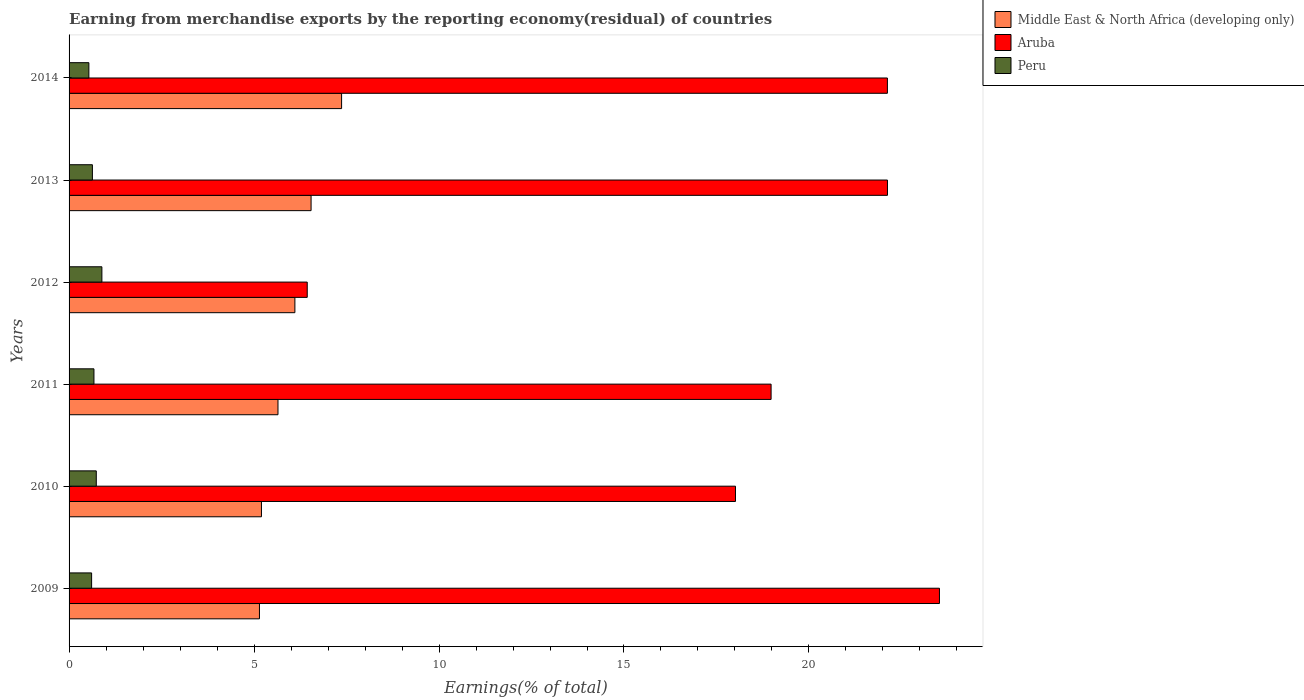Are the number of bars on each tick of the Y-axis equal?
Your response must be concise. Yes. How many bars are there on the 3rd tick from the bottom?
Give a very brief answer. 3. In how many cases, is the number of bars for a given year not equal to the number of legend labels?
Ensure brevity in your answer.  0. What is the percentage of amount earned from merchandise exports in Middle East & North Africa (developing only) in 2009?
Keep it short and to the point. 5.15. Across all years, what is the maximum percentage of amount earned from merchandise exports in Peru?
Make the answer very short. 0.89. Across all years, what is the minimum percentage of amount earned from merchandise exports in Peru?
Give a very brief answer. 0.54. In which year was the percentage of amount earned from merchandise exports in Peru maximum?
Provide a succinct answer. 2012. What is the total percentage of amount earned from merchandise exports in Aruba in the graph?
Make the answer very short. 111.2. What is the difference between the percentage of amount earned from merchandise exports in Middle East & North Africa (developing only) in 2011 and that in 2013?
Provide a short and direct response. -0.89. What is the difference between the percentage of amount earned from merchandise exports in Middle East & North Africa (developing only) in 2009 and the percentage of amount earned from merchandise exports in Peru in 2011?
Your answer should be very brief. 4.47. What is the average percentage of amount earned from merchandise exports in Aruba per year?
Provide a succinct answer. 18.53. In the year 2010, what is the difference between the percentage of amount earned from merchandise exports in Aruba and percentage of amount earned from merchandise exports in Peru?
Provide a short and direct response. 17.28. What is the ratio of the percentage of amount earned from merchandise exports in Peru in 2012 to that in 2014?
Give a very brief answer. 1.66. What is the difference between the highest and the second highest percentage of amount earned from merchandise exports in Peru?
Your response must be concise. 0.15. What is the difference between the highest and the lowest percentage of amount earned from merchandise exports in Aruba?
Make the answer very short. 17.09. In how many years, is the percentage of amount earned from merchandise exports in Aruba greater than the average percentage of amount earned from merchandise exports in Aruba taken over all years?
Your answer should be very brief. 4. Is the sum of the percentage of amount earned from merchandise exports in Peru in 2009 and 2012 greater than the maximum percentage of amount earned from merchandise exports in Middle East & North Africa (developing only) across all years?
Ensure brevity in your answer.  No. What does the 1st bar from the top in 2012 represents?
Offer a very short reply. Peru. What does the 3rd bar from the bottom in 2014 represents?
Offer a terse response. Peru. Is it the case that in every year, the sum of the percentage of amount earned from merchandise exports in Middle East & North Africa (developing only) and percentage of amount earned from merchandise exports in Aruba is greater than the percentage of amount earned from merchandise exports in Peru?
Keep it short and to the point. Yes. Are all the bars in the graph horizontal?
Offer a very short reply. Yes. Are the values on the major ticks of X-axis written in scientific E-notation?
Make the answer very short. No. Does the graph contain any zero values?
Provide a succinct answer. No. Does the graph contain grids?
Offer a terse response. No. How are the legend labels stacked?
Keep it short and to the point. Vertical. What is the title of the graph?
Give a very brief answer. Earning from merchandise exports by the reporting economy(residual) of countries. Does "Heavily indebted poor countries" appear as one of the legend labels in the graph?
Provide a succinct answer. No. What is the label or title of the X-axis?
Your response must be concise. Earnings(% of total). What is the label or title of the Y-axis?
Ensure brevity in your answer.  Years. What is the Earnings(% of total) of Middle East & North Africa (developing only) in 2009?
Give a very brief answer. 5.15. What is the Earnings(% of total) of Aruba in 2009?
Offer a terse response. 23.53. What is the Earnings(% of total) in Peru in 2009?
Provide a short and direct response. 0.61. What is the Earnings(% of total) in Middle East & North Africa (developing only) in 2010?
Your response must be concise. 5.2. What is the Earnings(% of total) in Aruba in 2010?
Your answer should be compact. 18.01. What is the Earnings(% of total) in Peru in 2010?
Give a very brief answer. 0.74. What is the Earnings(% of total) of Middle East & North Africa (developing only) in 2011?
Make the answer very short. 5.65. What is the Earnings(% of total) in Aruba in 2011?
Ensure brevity in your answer.  18.98. What is the Earnings(% of total) in Peru in 2011?
Make the answer very short. 0.67. What is the Earnings(% of total) of Middle East & North Africa (developing only) in 2012?
Make the answer very short. 6.1. What is the Earnings(% of total) of Aruba in 2012?
Offer a very short reply. 6.44. What is the Earnings(% of total) in Peru in 2012?
Make the answer very short. 0.89. What is the Earnings(% of total) in Middle East & North Africa (developing only) in 2013?
Offer a terse response. 6.54. What is the Earnings(% of total) in Aruba in 2013?
Offer a very short reply. 22.12. What is the Earnings(% of total) in Peru in 2013?
Ensure brevity in your answer.  0.63. What is the Earnings(% of total) of Middle East & North Africa (developing only) in 2014?
Give a very brief answer. 7.37. What is the Earnings(% of total) in Aruba in 2014?
Provide a succinct answer. 22.12. What is the Earnings(% of total) of Peru in 2014?
Give a very brief answer. 0.54. Across all years, what is the maximum Earnings(% of total) in Middle East & North Africa (developing only)?
Give a very brief answer. 7.37. Across all years, what is the maximum Earnings(% of total) of Aruba?
Keep it short and to the point. 23.53. Across all years, what is the maximum Earnings(% of total) of Peru?
Ensure brevity in your answer.  0.89. Across all years, what is the minimum Earnings(% of total) of Middle East & North Africa (developing only)?
Offer a very short reply. 5.15. Across all years, what is the minimum Earnings(% of total) of Aruba?
Offer a very short reply. 6.44. Across all years, what is the minimum Earnings(% of total) of Peru?
Your response must be concise. 0.54. What is the total Earnings(% of total) of Middle East & North Africa (developing only) in the graph?
Provide a succinct answer. 36.01. What is the total Earnings(% of total) of Aruba in the graph?
Give a very brief answer. 111.2. What is the total Earnings(% of total) in Peru in the graph?
Your response must be concise. 4.07. What is the difference between the Earnings(% of total) of Middle East & North Africa (developing only) in 2009 and that in 2010?
Keep it short and to the point. -0.05. What is the difference between the Earnings(% of total) of Aruba in 2009 and that in 2010?
Offer a very short reply. 5.51. What is the difference between the Earnings(% of total) in Peru in 2009 and that in 2010?
Give a very brief answer. -0.13. What is the difference between the Earnings(% of total) in Middle East & North Africa (developing only) in 2009 and that in 2011?
Ensure brevity in your answer.  -0.5. What is the difference between the Earnings(% of total) in Aruba in 2009 and that in 2011?
Give a very brief answer. 4.55. What is the difference between the Earnings(% of total) in Peru in 2009 and that in 2011?
Keep it short and to the point. -0.06. What is the difference between the Earnings(% of total) of Middle East & North Africa (developing only) in 2009 and that in 2012?
Provide a short and direct response. -0.96. What is the difference between the Earnings(% of total) in Aruba in 2009 and that in 2012?
Give a very brief answer. 17.09. What is the difference between the Earnings(% of total) of Peru in 2009 and that in 2012?
Give a very brief answer. -0.28. What is the difference between the Earnings(% of total) of Middle East & North Africa (developing only) in 2009 and that in 2013?
Your response must be concise. -1.4. What is the difference between the Earnings(% of total) in Aruba in 2009 and that in 2013?
Give a very brief answer. 1.41. What is the difference between the Earnings(% of total) of Peru in 2009 and that in 2013?
Make the answer very short. -0.02. What is the difference between the Earnings(% of total) of Middle East & North Africa (developing only) in 2009 and that in 2014?
Ensure brevity in your answer.  -2.22. What is the difference between the Earnings(% of total) in Aruba in 2009 and that in 2014?
Your response must be concise. 1.41. What is the difference between the Earnings(% of total) of Peru in 2009 and that in 2014?
Offer a terse response. 0.07. What is the difference between the Earnings(% of total) in Middle East & North Africa (developing only) in 2010 and that in 2011?
Provide a succinct answer. -0.45. What is the difference between the Earnings(% of total) of Aruba in 2010 and that in 2011?
Give a very brief answer. -0.96. What is the difference between the Earnings(% of total) in Peru in 2010 and that in 2011?
Your response must be concise. 0.06. What is the difference between the Earnings(% of total) of Middle East & North Africa (developing only) in 2010 and that in 2012?
Offer a very short reply. -0.9. What is the difference between the Earnings(% of total) of Aruba in 2010 and that in 2012?
Ensure brevity in your answer.  11.58. What is the difference between the Earnings(% of total) in Peru in 2010 and that in 2012?
Provide a short and direct response. -0.15. What is the difference between the Earnings(% of total) of Middle East & North Africa (developing only) in 2010 and that in 2013?
Provide a succinct answer. -1.34. What is the difference between the Earnings(% of total) in Aruba in 2010 and that in 2013?
Provide a succinct answer. -4.11. What is the difference between the Earnings(% of total) of Peru in 2010 and that in 2013?
Ensure brevity in your answer.  0.1. What is the difference between the Earnings(% of total) of Middle East & North Africa (developing only) in 2010 and that in 2014?
Give a very brief answer. -2.17. What is the difference between the Earnings(% of total) of Aruba in 2010 and that in 2014?
Make the answer very short. -4.11. What is the difference between the Earnings(% of total) in Peru in 2010 and that in 2014?
Give a very brief answer. 0.2. What is the difference between the Earnings(% of total) of Middle East & North Africa (developing only) in 2011 and that in 2012?
Give a very brief answer. -0.46. What is the difference between the Earnings(% of total) in Aruba in 2011 and that in 2012?
Your answer should be very brief. 12.54. What is the difference between the Earnings(% of total) in Peru in 2011 and that in 2012?
Your answer should be very brief. -0.21. What is the difference between the Earnings(% of total) in Middle East & North Africa (developing only) in 2011 and that in 2013?
Offer a very short reply. -0.89. What is the difference between the Earnings(% of total) of Aruba in 2011 and that in 2013?
Give a very brief answer. -3.15. What is the difference between the Earnings(% of total) of Peru in 2011 and that in 2013?
Your response must be concise. 0.04. What is the difference between the Earnings(% of total) in Middle East & North Africa (developing only) in 2011 and that in 2014?
Your answer should be compact. -1.72. What is the difference between the Earnings(% of total) of Aruba in 2011 and that in 2014?
Offer a terse response. -3.14. What is the difference between the Earnings(% of total) of Peru in 2011 and that in 2014?
Your response must be concise. 0.14. What is the difference between the Earnings(% of total) of Middle East & North Africa (developing only) in 2012 and that in 2013?
Offer a terse response. -0.44. What is the difference between the Earnings(% of total) of Aruba in 2012 and that in 2013?
Your answer should be very brief. -15.68. What is the difference between the Earnings(% of total) of Peru in 2012 and that in 2013?
Ensure brevity in your answer.  0.26. What is the difference between the Earnings(% of total) of Middle East & North Africa (developing only) in 2012 and that in 2014?
Your answer should be very brief. -1.26. What is the difference between the Earnings(% of total) of Aruba in 2012 and that in 2014?
Make the answer very short. -15.68. What is the difference between the Earnings(% of total) in Peru in 2012 and that in 2014?
Make the answer very short. 0.35. What is the difference between the Earnings(% of total) in Middle East & North Africa (developing only) in 2013 and that in 2014?
Keep it short and to the point. -0.82. What is the difference between the Earnings(% of total) of Aruba in 2013 and that in 2014?
Provide a short and direct response. 0. What is the difference between the Earnings(% of total) of Peru in 2013 and that in 2014?
Give a very brief answer. 0.1. What is the difference between the Earnings(% of total) of Middle East & North Africa (developing only) in 2009 and the Earnings(% of total) of Aruba in 2010?
Ensure brevity in your answer.  -12.87. What is the difference between the Earnings(% of total) in Middle East & North Africa (developing only) in 2009 and the Earnings(% of total) in Peru in 2010?
Your response must be concise. 4.41. What is the difference between the Earnings(% of total) of Aruba in 2009 and the Earnings(% of total) of Peru in 2010?
Your answer should be compact. 22.79. What is the difference between the Earnings(% of total) of Middle East & North Africa (developing only) in 2009 and the Earnings(% of total) of Aruba in 2011?
Your response must be concise. -13.83. What is the difference between the Earnings(% of total) in Middle East & North Africa (developing only) in 2009 and the Earnings(% of total) in Peru in 2011?
Your answer should be very brief. 4.47. What is the difference between the Earnings(% of total) of Aruba in 2009 and the Earnings(% of total) of Peru in 2011?
Provide a succinct answer. 22.85. What is the difference between the Earnings(% of total) in Middle East & North Africa (developing only) in 2009 and the Earnings(% of total) in Aruba in 2012?
Keep it short and to the point. -1.29. What is the difference between the Earnings(% of total) of Middle East & North Africa (developing only) in 2009 and the Earnings(% of total) of Peru in 2012?
Offer a very short reply. 4.26. What is the difference between the Earnings(% of total) in Aruba in 2009 and the Earnings(% of total) in Peru in 2012?
Offer a terse response. 22.64. What is the difference between the Earnings(% of total) of Middle East & North Africa (developing only) in 2009 and the Earnings(% of total) of Aruba in 2013?
Offer a very short reply. -16.98. What is the difference between the Earnings(% of total) of Middle East & North Africa (developing only) in 2009 and the Earnings(% of total) of Peru in 2013?
Ensure brevity in your answer.  4.52. What is the difference between the Earnings(% of total) of Aruba in 2009 and the Earnings(% of total) of Peru in 2013?
Provide a short and direct response. 22.9. What is the difference between the Earnings(% of total) in Middle East & North Africa (developing only) in 2009 and the Earnings(% of total) in Aruba in 2014?
Your answer should be very brief. -16.97. What is the difference between the Earnings(% of total) of Middle East & North Africa (developing only) in 2009 and the Earnings(% of total) of Peru in 2014?
Ensure brevity in your answer.  4.61. What is the difference between the Earnings(% of total) of Aruba in 2009 and the Earnings(% of total) of Peru in 2014?
Offer a very short reply. 22.99. What is the difference between the Earnings(% of total) in Middle East & North Africa (developing only) in 2010 and the Earnings(% of total) in Aruba in 2011?
Ensure brevity in your answer.  -13.78. What is the difference between the Earnings(% of total) in Middle East & North Africa (developing only) in 2010 and the Earnings(% of total) in Peru in 2011?
Provide a short and direct response. 4.53. What is the difference between the Earnings(% of total) in Aruba in 2010 and the Earnings(% of total) in Peru in 2011?
Your answer should be very brief. 17.34. What is the difference between the Earnings(% of total) of Middle East & North Africa (developing only) in 2010 and the Earnings(% of total) of Aruba in 2012?
Your answer should be compact. -1.24. What is the difference between the Earnings(% of total) in Middle East & North Africa (developing only) in 2010 and the Earnings(% of total) in Peru in 2012?
Make the answer very short. 4.31. What is the difference between the Earnings(% of total) of Aruba in 2010 and the Earnings(% of total) of Peru in 2012?
Your response must be concise. 17.13. What is the difference between the Earnings(% of total) of Middle East & North Africa (developing only) in 2010 and the Earnings(% of total) of Aruba in 2013?
Provide a succinct answer. -16.92. What is the difference between the Earnings(% of total) in Middle East & North Africa (developing only) in 2010 and the Earnings(% of total) in Peru in 2013?
Your response must be concise. 4.57. What is the difference between the Earnings(% of total) in Aruba in 2010 and the Earnings(% of total) in Peru in 2013?
Offer a terse response. 17.38. What is the difference between the Earnings(% of total) in Middle East & North Africa (developing only) in 2010 and the Earnings(% of total) in Aruba in 2014?
Your answer should be very brief. -16.92. What is the difference between the Earnings(% of total) of Middle East & North Africa (developing only) in 2010 and the Earnings(% of total) of Peru in 2014?
Keep it short and to the point. 4.67. What is the difference between the Earnings(% of total) of Aruba in 2010 and the Earnings(% of total) of Peru in 2014?
Provide a succinct answer. 17.48. What is the difference between the Earnings(% of total) in Middle East & North Africa (developing only) in 2011 and the Earnings(% of total) in Aruba in 2012?
Make the answer very short. -0.79. What is the difference between the Earnings(% of total) of Middle East & North Africa (developing only) in 2011 and the Earnings(% of total) of Peru in 2012?
Provide a short and direct response. 4.76. What is the difference between the Earnings(% of total) of Aruba in 2011 and the Earnings(% of total) of Peru in 2012?
Make the answer very short. 18.09. What is the difference between the Earnings(% of total) of Middle East & North Africa (developing only) in 2011 and the Earnings(% of total) of Aruba in 2013?
Give a very brief answer. -16.48. What is the difference between the Earnings(% of total) in Middle East & North Africa (developing only) in 2011 and the Earnings(% of total) in Peru in 2013?
Your response must be concise. 5.02. What is the difference between the Earnings(% of total) in Aruba in 2011 and the Earnings(% of total) in Peru in 2013?
Your answer should be very brief. 18.35. What is the difference between the Earnings(% of total) in Middle East & North Africa (developing only) in 2011 and the Earnings(% of total) in Aruba in 2014?
Give a very brief answer. -16.47. What is the difference between the Earnings(% of total) in Middle East & North Africa (developing only) in 2011 and the Earnings(% of total) in Peru in 2014?
Offer a terse response. 5.11. What is the difference between the Earnings(% of total) of Aruba in 2011 and the Earnings(% of total) of Peru in 2014?
Give a very brief answer. 18.44. What is the difference between the Earnings(% of total) in Middle East & North Africa (developing only) in 2012 and the Earnings(% of total) in Aruba in 2013?
Offer a very short reply. -16.02. What is the difference between the Earnings(% of total) in Middle East & North Africa (developing only) in 2012 and the Earnings(% of total) in Peru in 2013?
Your response must be concise. 5.47. What is the difference between the Earnings(% of total) in Aruba in 2012 and the Earnings(% of total) in Peru in 2013?
Provide a succinct answer. 5.81. What is the difference between the Earnings(% of total) of Middle East & North Africa (developing only) in 2012 and the Earnings(% of total) of Aruba in 2014?
Make the answer very short. -16.02. What is the difference between the Earnings(% of total) in Middle East & North Africa (developing only) in 2012 and the Earnings(% of total) in Peru in 2014?
Your answer should be compact. 5.57. What is the difference between the Earnings(% of total) of Aruba in 2012 and the Earnings(% of total) of Peru in 2014?
Make the answer very short. 5.9. What is the difference between the Earnings(% of total) in Middle East & North Africa (developing only) in 2013 and the Earnings(% of total) in Aruba in 2014?
Provide a succinct answer. -15.58. What is the difference between the Earnings(% of total) of Middle East & North Africa (developing only) in 2013 and the Earnings(% of total) of Peru in 2014?
Your answer should be compact. 6.01. What is the difference between the Earnings(% of total) of Aruba in 2013 and the Earnings(% of total) of Peru in 2014?
Provide a short and direct response. 21.59. What is the average Earnings(% of total) of Middle East & North Africa (developing only) per year?
Your answer should be very brief. 6. What is the average Earnings(% of total) of Aruba per year?
Your response must be concise. 18.53. What is the average Earnings(% of total) in Peru per year?
Your response must be concise. 0.68. In the year 2009, what is the difference between the Earnings(% of total) in Middle East & North Africa (developing only) and Earnings(% of total) in Aruba?
Provide a short and direct response. -18.38. In the year 2009, what is the difference between the Earnings(% of total) of Middle East & North Africa (developing only) and Earnings(% of total) of Peru?
Make the answer very short. 4.54. In the year 2009, what is the difference between the Earnings(% of total) in Aruba and Earnings(% of total) in Peru?
Your answer should be compact. 22.92. In the year 2010, what is the difference between the Earnings(% of total) of Middle East & North Africa (developing only) and Earnings(% of total) of Aruba?
Your answer should be compact. -12.81. In the year 2010, what is the difference between the Earnings(% of total) in Middle East & North Africa (developing only) and Earnings(% of total) in Peru?
Give a very brief answer. 4.46. In the year 2010, what is the difference between the Earnings(% of total) in Aruba and Earnings(% of total) in Peru?
Ensure brevity in your answer.  17.28. In the year 2011, what is the difference between the Earnings(% of total) in Middle East & North Africa (developing only) and Earnings(% of total) in Aruba?
Make the answer very short. -13.33. In the year 2011, what is the difference between the Earnings(% of total) of Middle East & North Africa (developing only) and Earnings(% of total) of Peru?
Offer a very short reply. 4.97. In the year 2011, what is the difference between the Earnings(% of total) of Aruba and Earnings(% of total) of Peru?
Your answer should be compact. 18.3. In the year 2012, what is the difference between the Earnings(% of total) of Middle East & North Africa (developing only) and Earnings(% of total) of Aruba?
Offer a very short reply. -0.33. In the year 2012, what is the difference between the Earnings(% of total) of Middle East & North Africa (developing only) and Earnings(% of total) of Peru?
Make the answer very short. 5.22. In the year 2012, what is the difference between the Earnings(% of total) in Aruba and Earnings(% of total) in Peru?
Your answer should be very brief. 5.55. In the year 2013, what is the difference between the Earnings(% of total) of Middle East & North Africa (developing only) and Earnings(% of total) of Aruba?
Provide a short and direct response. -15.58. In the year 2013, what is the difference between the Earnings(% of total) of Middle East & North Africa (developing only) and Earnings(% of total) of Peru?
Provide a succinct answer. 5.91. In the year 2013, what is the difference between the Earnings(% of total) of Aruba and Earnings(% of total) of Peru?
Offer a terse response. 21.49. In the year 2014, what is the difference between the Earnings(% of total) of Middle East & North Africa (developing only) and Earnings(% of total) of Aruba?
Keep it short and to the point. -14.75. In the year 2014, what is the difference between the Earnings(% of total) of Middle East & North Africa (developing only) and Earnings(% of total) of Peru?
Offer a terse response. 6.83. In the year 2014, what is the difference between the Earnings(% of total) of Aruba and Earnings(% of total) of Peru?
Your answer should be compact. 21.59. What is the ratio of the Earnings(% of total) of Aruba in 2009 to that in 2010?
Your answer should be very brief. 1.31. What is the ratio of the Earnings(% of total) in Peru in 2009 to that in 2010?
Offer a very short reply. 0.83. What is the ratio of the Earnings(% of total) of Middle East & North Africa (developing only) in 2009 to that in 2011?
Your answer should be very brief. 0.91. What is the ratio of the Earnings(% of total) of Aruba in 2009 to that in 2011?
Offer a very short reply. 1.24. What is the ratio of the Earnings(% of total) in Peru in 2009 to that in 2011?
Your response must be concise. 0.91. What is the ratio of the Earnings(% of total) in Middle East & North Africa (developing only) in 2009 to that in 2012?
Make the answer very short. 0.84. What is the ratio of the Earnings(% of total) of Aruba in 2009 to that in 2012?
Ensure brevity in your answer.  3.65. What is the ratio of the Earnings(% of total) of Peru in 2009 to that in 2012?
Keep it short and to the point. 0.69. What is the ratio of the Earnings(% of total) in Middle East & North Africa (developing only) in 2009 to that in 2013?
Your response must be concise. 0.79. What is the ratio of the Earnings(% of total) of Aruba in 2009 to that in 2013?
Your answer should be compact. 1.06. What is the ratio of the Earnings(% of total) in Peru in 2009 to that in 2013?
Your answer should be very brief. 0.97. What is the ratio of the Earnings(% of total) of Middle East & North Africa (developing only) in 2009 to that in 2014?
Your answer should be very brief. 0.7. What is the ratio of the Earnings(% of total) of Aruba in 2009 to that in 2014?
Your response must be concise. 1.06. What is the ratio of the Earnings(% of total) in Peru in 2009 to that in 2014?
Provide a short and direct response. 1.14. What is the ratio of the Earnings(% of total) of Middle East & North Africa (developing only) in 2010 to that in 2011?
Offer a very short reply. 0.92. What is the ratio of the Earnings(% of total) in Aruba in 2010 to that in 2011?
Keep it short and to the point. 0.95. What is the ratio of the Earnings(% of total) in Peru in 2010 to that in 2011?
Offer a terse response. 1.09. What is the ratio of the Earnings(% of total) of Middle East & North Africa (developing only) in 2010 to that in 2012?
Offer a very short reply. 0.85. What is the ratio of the Earnings(% of total) of Aruba in 2010 to that in 2012?
Ensure brevity in your answer.  2.8. What is the ratio of the Earnings(% of total) in Peru in 2010 to that in 2012?
Ensure brevity in your answer.  0.83. What is the ratio of the Earnings(% of total) in Middle East & North Africa (developing only) in 2010 to that in 2013?
Provide a short and direct response. 0.8. What is the ratio of the Earnings(% of total) in Aruba in 2010 to that in 2013?
Your answer should be very brief. 0.81. What is the ratio of the Earnings(% of total) in Peru in 2010 to that in 2013?
Your answer should be compact. 1.17. What is the ratio of the Earnings(% of total) of Middle East & North Africa (developing only) in 2010 to that in 2014?
Provide a succinct answer. 0.71. What is the ratio of the Earnings(% of total) of Aruba in 2010 to that in 2014?
Make the answer very short. 0.81. What is the ratio of the Earnings(% of total) of Peru in 2010 to that in 2014?
Ensure brevity in your answer.  1.37. What is the ratio of the Earnings(% of total) in Middle East & North Africa (developing only) in 2011 to that in 2012?
Ensure brevity in your answer.  0.93. What is the ratio of the Earnings(% of total) of Aruba in 2011 to that in 2012?
Keep it short and to the point. 2.95. What is the ratio of the Earnings(% of total) of Peru in 2011 to that in 2012?
Keep it short and to the point. 0.76. What is the ratio of the Earnings(% of total) of Middle East & North Africa (developing only) in 2011 to that in 2013?
Provide a succinct answer. 0.86. What is the ratio of the Earnings(% of total) of Aruba in 2011 to that in 2013?
Keep it short and to the point. 0.86. What is the ratio of the Earnings(% of total) in Peru in 2011 to that in 2013?
Make the answer very short. 1.07. What is the ratio of the Earnings(% of total) in Middle East & North Africa (developing only) in 2011 to that in 2014?
Your response must be concise. 0.77. What is the ratio of the Earnings(% of total) in Aruba in 2011 to that in 2014?
Offer a very short reply. 0.86. What is the ratio of the Earnings(% of total) in Peru in 2011 to that in 2014?
Provide a succinct answer. 1.26. What is the ratio of the Earnings(% of total) in Middle East & North Africa (developing only) in 2012 to that in 2013?
Offer a terse response. 0.93. What is the ratio of the Earnings(% of total) of Aruba in 2012 to that in 2013?
Ensure brevity in your answer.  0.29. What is the ratio of the Earnings(% of total) of Peru in 2012 to that in 2013?
Your answer should be very brief. 1.41. What is the ratio of the Earnings(% of total) in Middle East & North Africa (developing only) in 2012 to that in 2014?
Your answer should be compact. 0.83. What is the ratio of the Earnings(% of total) of Aruba in 2012 to that in 2014?
Give a very brief answer. 0.29. What is the ratio of the Earnings(% of total) in Peru in 2012 to that in 2014?
Provide a short and direct response. 1.66. What is the ratio of the Earnings(% of total) in Middle East & North Africa (developing only) in 2013 to that in 2014?
Keep it short and to the point. 0.89. What is the ratio of the Earnings(% of total) of Aruba in 2013 to that in 2014?
Make the answer very short. 1. What is the ratio of the Earnings(% of total) of Peru in 2013 to that in 2014?
Ensure brevity in your answer.  1.18. What is the difference between the highest and the second highest Earnings(% of total) of Middle East & North Africa (developing only)?
Ensure brevity in your answer.  0.82. What is the difference between the highest and the second highest Earnings(% of total) in Aruba?
Ensure brevity in your answer.  1.41. What is the difference between the highest and the second highest Earnings(% of total) of Peru?
Give a very brief answer. 0.15. What is the difference between the highest and the lowest Earnings(% of total) of Middle East & North Africa (developing only)?
Offer a terse response. 2.22. What is the difference between the highest and the lowest Earnings(% of total) of Aruba?
Offer a terse response. 17.09. What is the difference between the highest and the lowest Earnings(% of total) of Peru?
Your answer should be compact. 0.35. 